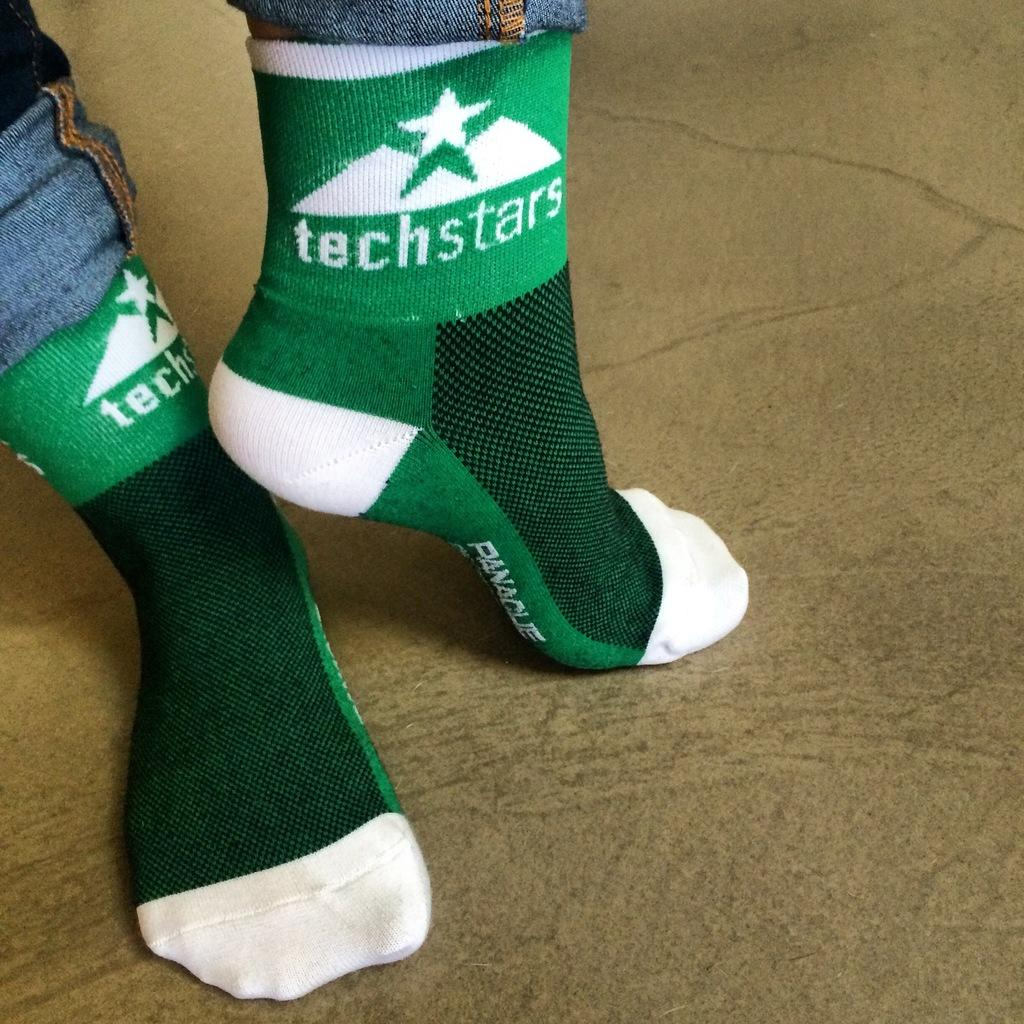What is present in the image? There is a person in the image. What type of clothing is covering the person's legs? The person's legs are covered with pants and socks. What is visible beneath the person's feet? There is ground visible in the image. What type of patch can be seen on the person's chin in the image? There is no patch visible on the person's chin in the image. 